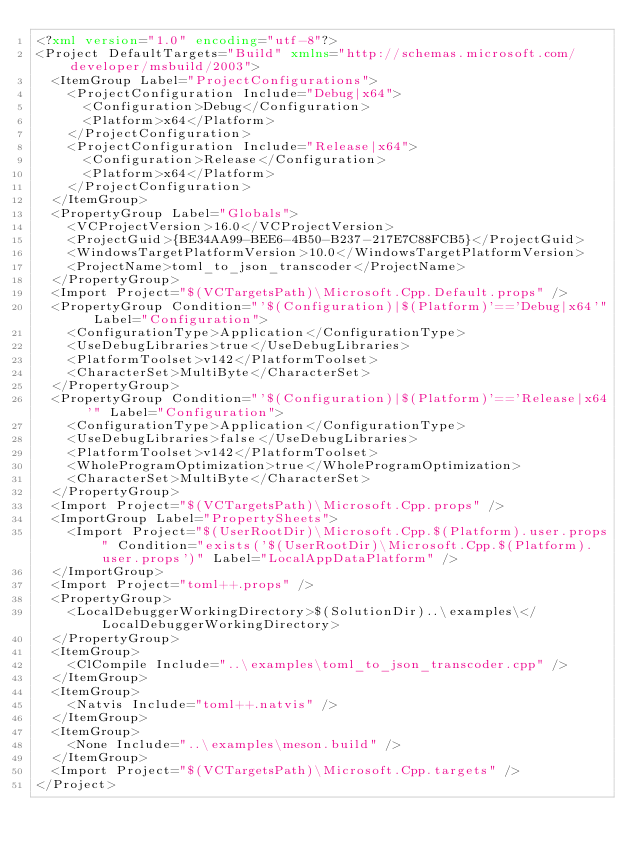Convert code to text. <code><loc_0><loc_0><loc_500><loc_500><_XML_><?xml version="1.0" encoding="utf-8"?>
<Project DefaultTargets="Build" xmlns="http://schemas.microsoft.com/developer/msbuild/2003">
  <ItemGroup Label="ProjectConfigurations">
    <ProjectConfiguration Include="Debug|x64">
      <Configuration>Debug</Configuration>
      <Platform>x64</Platform>
    </ProjectConfiguration>
    <ProjectConfiguration Include="Release|x64">
      <Configuration>Release</Configuration>
      <Platform>x64</Platform>
    </ProjectConfiguration>
  </ItemGroup>
  <PropertyGroup Label="Globals">
    <VCProjectVersion>16.0</VCProjectVersion>
    <ProjectGuid>{BE34AA99-BEE6-4B50-B237-217E7C88FCB5}</ProjectGuid>
    <WindowsTargetPlatformVersion>10.0</WindowsTargetPlatformVersion>
    <ProjectName>toml_to_json_transcoder</ProjectName>
  </PropertyGroup>
  <Import Project="$(VCTargetsPath)\Microsoft.Cpp.Default.props" />
  <PropertyGroup Condition="'$(Configuration)|$(Platform)'=='Debug|x64'" Label="Configuration">
    <ConfigurationType>Application</ConfigurationType>
    <UseDebugLibraries>true</UseDebugLibraries>
    <PlatformToolset>v142</PlatformToolset>
    <CharacterSet>MultiByte</CharacterSet>
  </PropertyGroup>
  <PropertyGroup Condition="'$(Configuration)|$(Platform)'=='Release|x64'" Label="Configuration">
    <ConfigurationType>Application</ConfigurationType>
    <UseDebugLibraries>false</UseDebugLibraries>
    <PlatformToolset>v142</PlatformToolset>
    <WholeProgramOptimization>true</WholeProgramOptimization>
    <CharacterSet>MultiByte</CharacterSet>
  </PropertyGroup>
  <Import Project="$(VCTargetsPath)\Microsoft.Cpp.props" />
  <ImportGroup Label="PropertySheets">
    <Import Project="$(UserRootDir)\Microsoft.Cpp.$(Platform).user.props" Condition="exists('$(UserRootDir)\Microsoft.Cpp.$(Platform).user.props')" Label="LocalAppDataPlatform" />
  </ImportGroup>
  <Import Project="toml++.props" />
  <PropertyGroup>
    <LocalDebuggerWorkingDirectory>$(SolutionDir)..\examples\</LocalDebuggerWorkingDirectory>
  </PropertyGroup>
  <ItemGroup>
    <ClCompile Include="..\examples\toml_to_json_transcoder.cpp" />
  </ItemGroup>
  <ItemGroup>
    <Natvis Include="toml++.natvis" />
  </ItemGroup>
  <ItemGroup>
    <None Include="..\examples\meson.build" />
  </ItemGroup>
  <Import Project="$(VCTargetsPath)\Microsoft.Cpp.targets" />
</Project></code> 